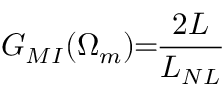Convert formula to latex. <formula><loc_0><loc_0><loc_500><loc_500>G _ { M I } ( \Omega _ { m } ) \, = \, \frac { 2 L } { L _ { N L } }</formula> 